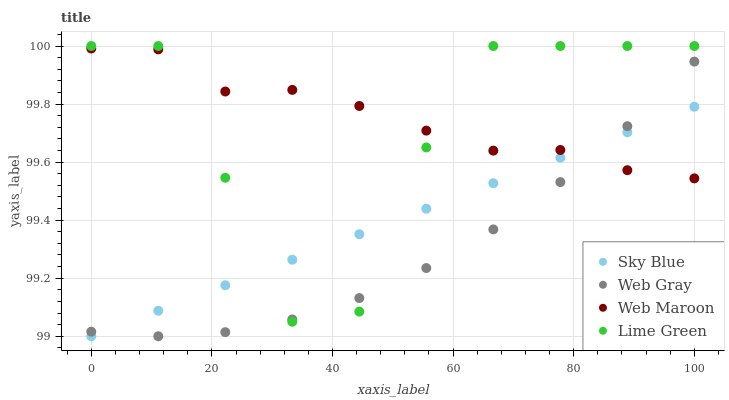Does Web Gray have the minimum area under the curve?
Answer yes or no. Yes. Does Web Maroon have the maximum area under the curve?
Answer yes or no. Yes. Does Web Maroon have the minimum area under the curve?
Answer yes or no. No. Does Web Gray have the maximum area under the curve?
Answer yes or no. No. Is Sky Blue the smoothest?
Answer yes or no. Yes. Is Lime Green the roughest?
Answer yes or no. Yes. Is Web Gray the smoothest?
Answer yes or no. No. Is Web Gray the roughest?
Answer yes or no. No. Does Sky Blue have the lowest value?
Answer yes or no. Yes. Does Web Gray have the lowest value?
Answer yes or no. No. Does Lime Green have the highest value?
Answer yes or no. Yes. Does Web Gray have the highest value?
Answer yes or no. No. Does Web Gray intersect Lime Green?
Answer yes or no. Yes. Is Web Gray less than Lime Green?
Answer yes or no. No. Is Web Gray greater than Lime Green?
Answer yes or no. No. 